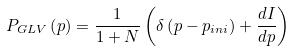<formula> <loc_0><loc_0><loc_500><loc_500>P _ { G L V } \left ( p \right ) = \frac { 1 } { 1 + N } \left ( \delta \left ( p - p _ { i n i } \right ) + \frac { d I } { d p } \right )</formula> 